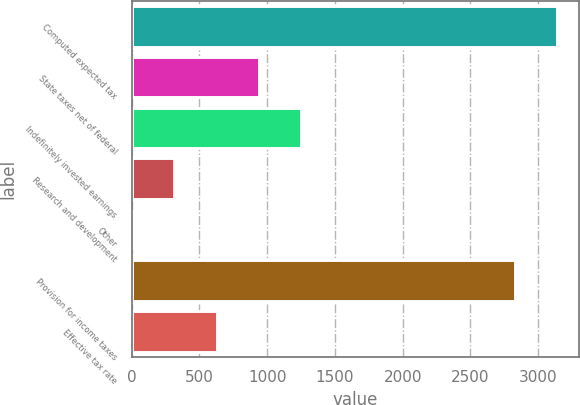Convert chart. <chart><loc_0><loc_0><loc_500><loc_500><bar_chart><fcel>Computed expected tax<fcel>State taxes net of federal<fcel>Indefinitely invested earnings<fcel>Research and development<fcel>Other<fcel>Provision for income taxes<fcel>Effective tax rate<nl><fcel>3141<fcel>940<fcel>1253<fcel>314<fcel>1<fcel>2828<fcel>627<nl></chart> 